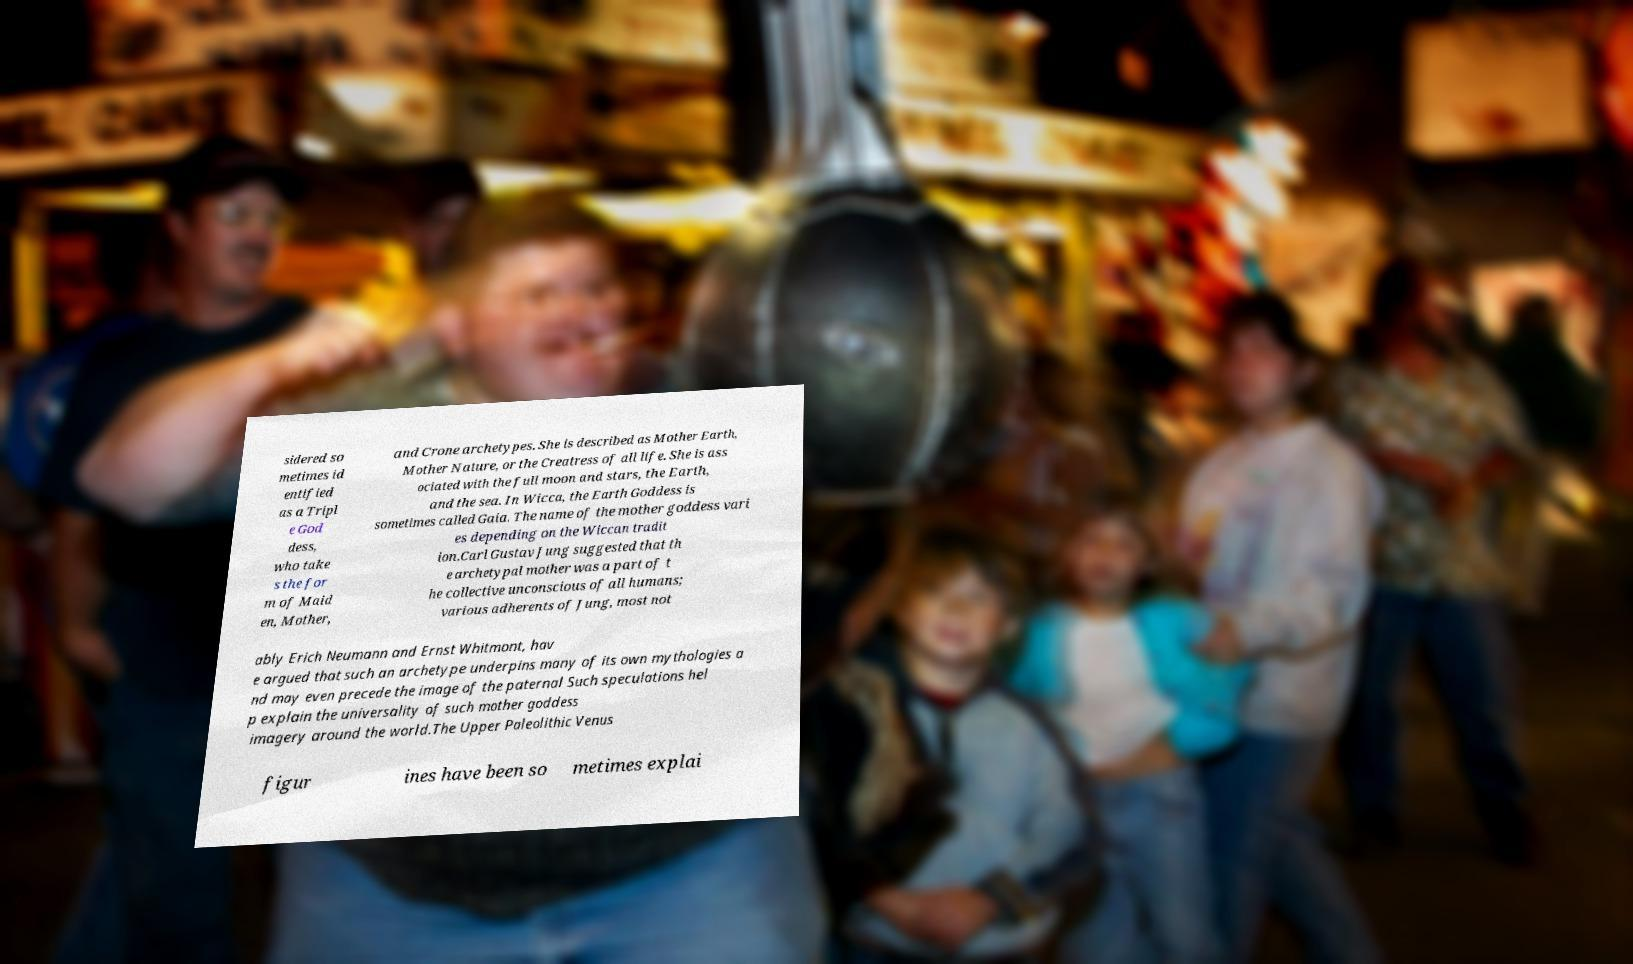Could you extract and type out the text from this image? sidered so metimes id entified as a Tripl e God dess, who take s the for m of Maid en, Mother, and Crone archetypes. She is described as Mother Earth, Mother Nature, or the Creatress of all life. She is ass ociated with the full moon and stars, the Earth, and the sea. In Wicca, the Earth Goddess is sometimes called Gaia. The name of the mother goddess vari es depending on the Wiccan tradit ion.Carl Gustav Jung suggested that th e archetypal mother was a part of t he collective unconscious of all humans; various adherents of Jung, most not ably Erich Neumann and Ernst Whitmont, hav e argued that such an archetype underpins many of its own mythologies a nd may even precede the image of the paternal Such speculations hel p explain the universality of such mother goddess imagery around the world.The Upper Paleolithic Venus figur ines have been so metimes explai 